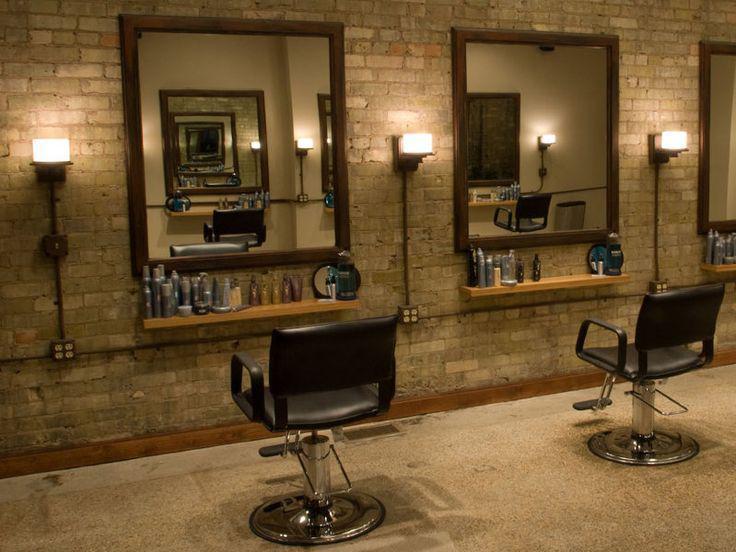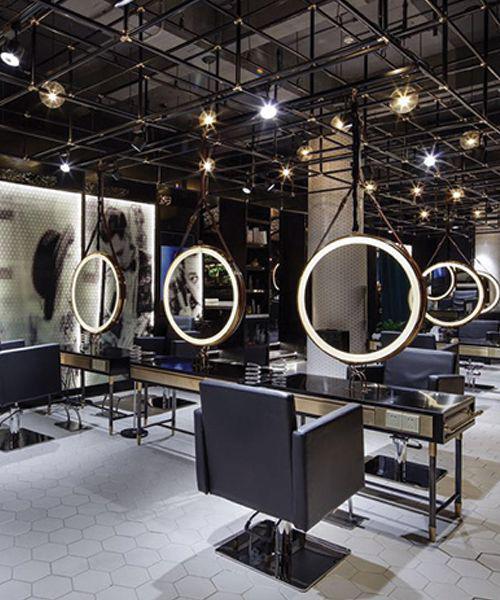The first image is the image on the left, the second image is the image on the right. Assess this claim about the two images: "One image is the interior of a barber shop and one image is the exterior of a barber shop". Correct or not? Answer yes or no. No. The first image is the image on the left, the second image is the image on the right. Examine the images to the left and right. Is the description "There is a barber pole in one of the iamges." accurate? Answer yes or no. No. 